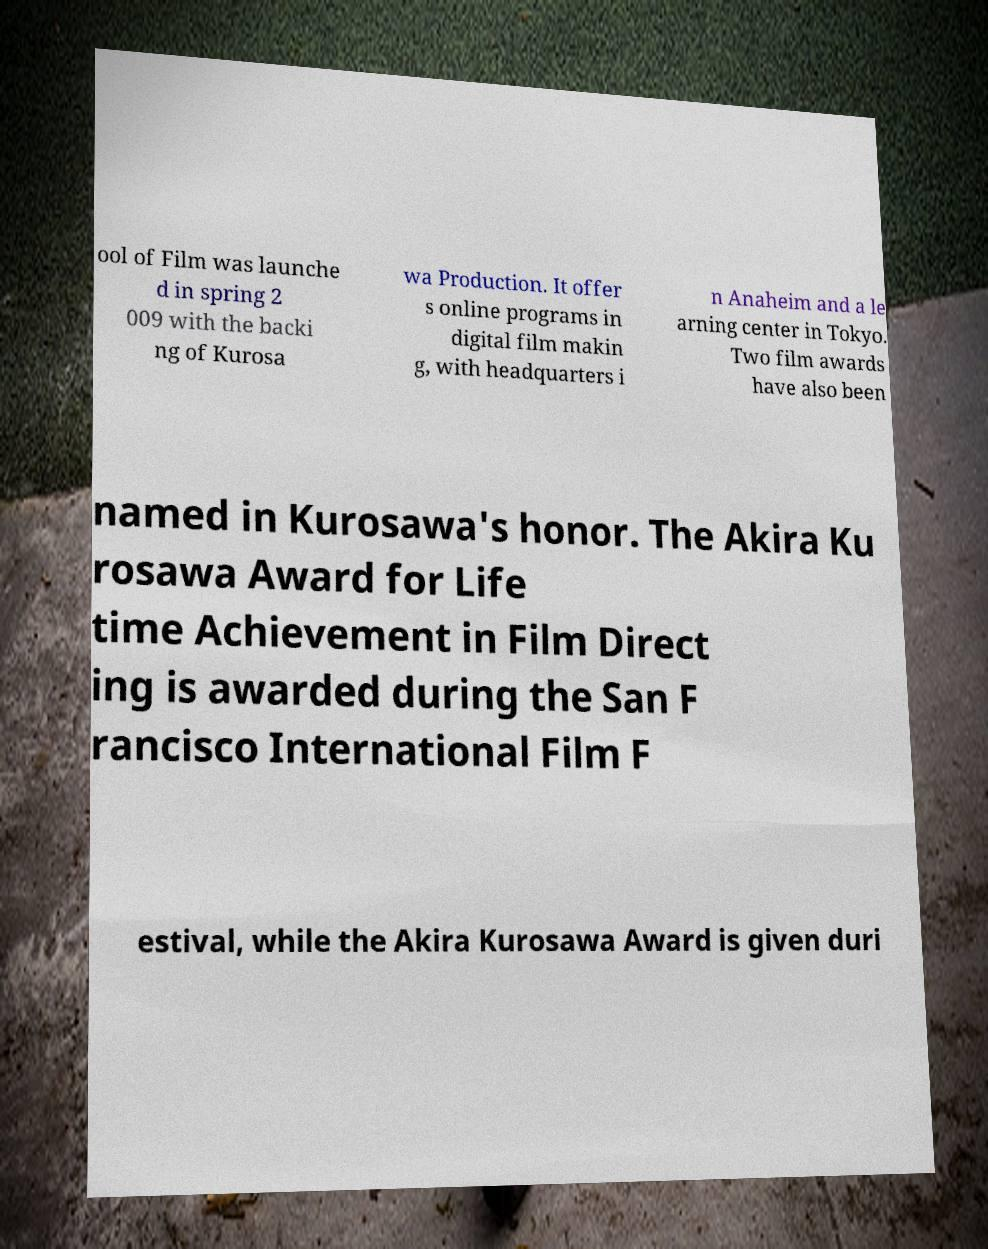Can you read and provide the text displayed in the image?This photo seems to have some interesting text. Can you extract and type it out for me? ool of Film was launche d in spring 2 009 with the backi ng of Kurosa wa Production. It offer s online programs in digital film makin g, with headquarters i n Anaheim and a le arning center in Tokyo. Two film awards have also been named in Kurosawa's honor. The Akira Ku rosawa Award for Life time Achievement in Film Direct ing is awarded during the San F rancisco International Film F estival, while the Akira Kurosawa Award is given duri 